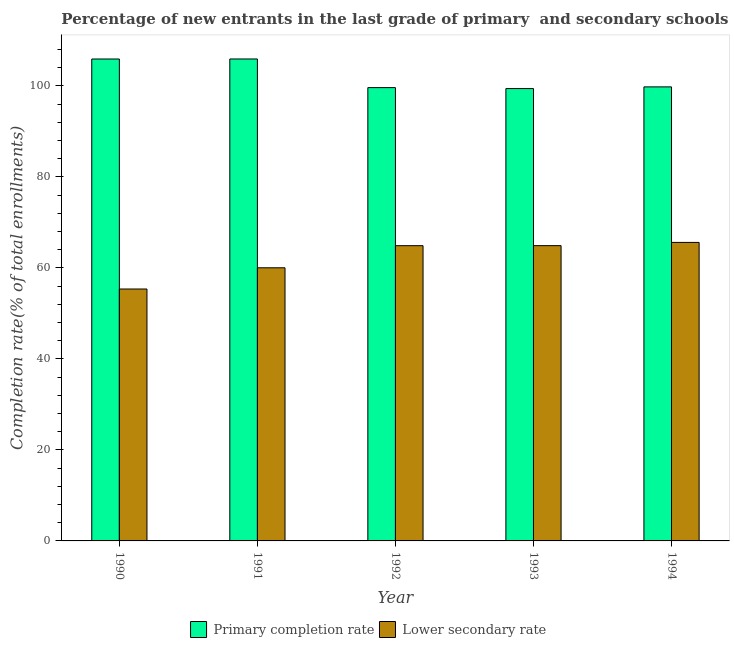How many different coloured bars are there?
Give a very brief answer. 2. How many groups of bars are there?
Keep it short and to the point. 5. In how many cases, is the number of bars for a given year not equal to the number of legend labels?
Provide a short and direct response. 0. What is the completion rate in primary schools in 1993?
Give a very brief answer. 99.42. Across all years, what is the maximum completion rate in primary schools?
Ensure brevity in your answer.  105.93. Across all years, what is the minimum completion rate in primary schools?
Give a very brief answer. 99.42. What is the total completion rate in secondary schools in the graph?
Keep it short and to the point. 310.79. What is the difference between the completion rate in secondary schools in 1992 and that in 1993?
Provide a short and direct response. -0.01. What is the difference between the completion rate in primary schools in 1994 and the completion rate in secondary schools in 1991?
Your answer should be very brief. -6.13. What is the average completion rate in primary schools per year?
Your answer should be compact. 102.14. In how many years, is the completion rate in secondary schools greater than 84 %?
Keep it short and to the point. 0. What is the ratio of the completion rate in secondary schools in 1990 to that in 1991?
Offer a terse response. 0.92. Is the difference between the completion rate in primary schools in 1992 and 1994 greater than the difference between the completion rate in secondary schools in 1992 and 1994?
Provide a succinct answer. No. What is the difference between the highest and the second highest completion rate in secondary schools?
Your response must be concise. 0.71. What is the difference between the highest and the lowest completion rate in primary schools?
Your answer should be compact. 6.5. In how many years, is the completion rate in secondary schools greater than the average completion rate in secondary schools taken over all years?
Your answer should be compact. 3. What does the 2nd bar from the left in 1990 represents?
Provide a short and direct response. Lower secondary rate. What does the 2nd bar from the right in 1992 represents?
Make the answer very short. Primary completion rate. What is the difference between two consecutive major ticks on the Y-axis?
Your answer should be compact. 20. Where does the legend appear in the graph?
Your answer should be compact. Bottom center. How many legend labels are there?
Ensure brevity in your answer.  2. What is the title of the graph?
Offer a very short reply. Percentage of new entrants in the last grade of primary  and secondary schools in China. What is the label or title of the X-axis?
Give a very brief answer. Year. What is the label or title of the Y-axis?
Ensure brevity in your answer.  Completion rate(% of total enrollments). What is the Completion rate(% of total enrollments) of Primary completion rate in 1990?
Make the answer very short. 105.92. What is the Completion rate(% of total enrollments) of Lower secondary rate in 1990?
Offer a terse response. 55.37. What is the Completion rate(% of total enrollments) of Primary completion rate in 1991?
Your response must be concise. 105.93. What is the Completion rate(% of total enrollments) of Lower secondary rate in 1991?
Provide a succinct answer. 60.03. What is the Completion rate(% of total enrollments) in Primary completion rate in 1992?
Ensure brevity in your answer.  99.63. What is the Completion rate(% of total enrollments) in Lower secondary rate in 1992?
Your answer should be very brief. 64.89. What is the Completion rate(% of total enrollments) of Primary completion rate in 1993?
Offer a very short reply. 99.42. What is the Completion rate(% of total enrollments) in Lower secondary rate in 1993?
Give a very brief answer. 64.9. What is the Completion rate(% of total enrollments) of Primary completion rate in 1994?
Provide a short and direct response. 99.79. What is the Completion rate(% of total enrollments) of Lower secondary rate in 1994?
Provide a short and direct response. 65.61. Across all years, what is the maximum Completion rate(% of total enrollments) of Primary completion rate?
Your answer should be very brief. 105.93. Across all years, what is the maximum Completion rate(% of total enrollments) of Lower secondary rate?
Offer a terse response. 65.61. Across all years, what is the minimum Completion rate(% of total enrollments) in Primary completion rate?
Offer a terse response. 99.42. Across all years, what is the minimum Completion rate(% of total enrollments) of Lower secondary rate?
Provide a short and direct response. 55.37. What is the total Completion rate(% of total enrollments) of Primary completion rate in the graph?
Offer a very short reply. 510.68. What is the total Completion rate(% of total enrollments) in Lower secondary rate in the graph?
Ensure brevity in your answer.  310.79. What is the difference between the Completion rate(% of total enrollments) in Primary completion rate in 1990 and that in 1991?
Provide a succinct answer. -0.01. What is the difference between the Completion rate(% of total enrollments) in Lower secondary rate in 1990 and that in 1991?
Your answer should be very brief. -4.66. What is the difference between the Completion rate(% of total enrollments) in Primary completion rate in 1990 and that in 1992?
Offer a very short reply. 6.29. What is the difference between the Completion rate(% of total enrollments) in Lower secondary rate in 1990 and that in 1992?
Ensure brevity in your answer.  -9.52. What is the difference between the Completion rate(% of total enrollments) of Primary completion rate in 1990 and that in 1993?
Your answer should be compact. 6.5. What is the difference between the Completion rate(% of total enrollments) of Lower secondary rate in 1990 and that in 1993?
Your answer should be very brief. -9.53. What is the difference between the Completion rate(% of total enrollments) of Primary completion rate in 1990 and that in 1994?
Ensure brevity in your answer.  6.13. What is the difference between the Completion rate(% of total enrollments) in Lower secondary rate in 1990 and that in 1994?
Ensure brevity in your answer.  -10.24. What is the difference between the Completion rate(% of total enrollments) in Primary completion rate in 1991 and that in 1992?
Give a very brief answer. 6.3. What is the difference between the Completion rate(% of total enrollments) in Lower secondary rate in 1991 and that in 1992?
Your response must be concise. -4.86. What is the difference between the Completion rate(% of total enrollments) in Primary completion rate in 1991 and that in 1993?
Your answer should be very brief. 6.5. What is the difference between the Completion rate(% of total enrollments) in Lower secondary rate in 1991 and that in 1993?
Give a very brief answer. -4.87. What is the difference between the Completion rate(% of total enrollments) in Primary completion rate in 1991 and that in 1994?
Your answer should be compact. 6.13. What is the difference between the Completion rate(% of total enrollments) in Lower secondary rate in 1991 and that in 1994?
Your response must be concise. -5.58. What is the difference between the Completion rate(% of total enrollments) in Primary completion rate in 1992 and that in 1993?
Your response must be concise. 0.21. What is the difference between the Completion rate(% of total enrollments) of Lower secondary rate in 1992 and that in 1993?
Give a very brief answer. -0.01. What is the difference between the Completion rate(% of total enrollments) of Primary completion rate in 1992 and that in 1994?
Your answer should be compact. -0.16. What is the difference between the Completion rate(% of total enrollments) of Lower secondary rate in 1992 and that in 1994?
Offer a very short reply. -0.72. What is the difference between the Completion rate(% of total enrollments) in Primary completion rate in 1993 and that in 1994?
Your answer should be compact. -0.37. What is the difference between the Completion rate(% of total enrollments) in Lower secondary rate in 1993 and that in 1994?
Offer a very short reply. -0.71. What is the difference between the Completion rate(% of total enrollments) of Primary completion rate in 1990 and the Completion rate(% of total enrollments) of Lower secondary rate in 1991?
Provide a succinct answer. 45.89. What is the difference between the Completion rate(% of total enrollments) of Primary completion rate in 1990 and the Completion rate(% of total enrollments) of Lower secondary rate in 1992?
Your answer should be very brief. 41.03. What is the difference between the Completion rate(% of total enrollments) of Primary completion rate in 1990 and the Completion rate(% of total enrollments) of Lower secondary rate in 1993?
Offer a very short reply. 41.02. What is the difference between the Completion rate(% of total enrollments) in Primary completion rate in 1990 and the Completion rate(% of total enrollments) in Lower secondary rate in 1994?
Provide a succinct answer. 40.31. What is the difference between the Completion rate(% of total enrollments) in Primary completion rate in 1991 and the Completion rate(% of total enrollments) in Lower secondary rate in 1992?
Provide a short and direct response. 41.03. What is the difference between the Completion rate(% of total enrollments) in Primary completion rate in 1991 and the Completion rate(% of total enrollments) in Lower secondary rate in 1993?
Provide a short and direct response. 41.03. What is the difference between the Completion rate(% of total enrollments) in Primary completion rate in 1991 and the Completion rate(% of total enrollments) in Lower secondary rate in 1994?
Provide a short and direct response. 40.32. What is the difference between the Completion rate(% of total enrollments) in Primary completion rate in 1992 and the Completion rate(% of total enrollments) in Lower secondary rate in 1993?
Keep it short and to the point. 34.73. What is the difference between the Completion rate(% of total enrollments) of Primary completion rate in 1992 and the Completion rate(% of total enrollments) of Lower secondary rate in 1994?
Keep it short and to the point. 34.02. What is the difference between the Completion rate(% of total enrollments) in Primary completion rate in 1993 and the Completion rate(% of total enrollments) in Lower secondary rate in 1994?
Your response must be concise. 33.81. What is the average Completion rate(% of total enrollments) of Primary completion rate per year?
Make the answer very short. 102.14. What is the average Completion rate(% of total enrollments) in Lower secondary rate per year?
Your answer should be compact. 62.16. In the year 1990, what is the difference between the Completion rate(% of total enrollments) in Primary completion rate and Completion rate(% of total enrollments) in Lower secondary rate?
Your answer should be compact. 50.55. In the year 1991, what is the difference between the Completion rate(% of total enrollments) of Primary completion rate and Completion rate(% of total enrollments) of Lower secondary rate?
Make the answer very short. 45.9. In the year 1992, what is the difference between the Completion rate(% of total enrollments) in Primary completion rate and Completion rate(% of total enrollments) in Lower secondary rate?
Offer a very short reply. 34.74. In the year 1993, what is the difference between the Completion rate(% of total enrollments) in Primary completion rate and Completion rate(% of total enrollments) in Lower secondary rate?
Your answer should be very brief. 34.52. In the year 1994, what is the difference between the Completion rate(% of total enrollments) in Primary completion rate and Completion rate(% of total enrollments) in Lower secondary rate?
Your answer should be compact. 34.18. What is the ratio of the Completion rate(% of total enrollments) of Primary completion rate in 1990 to that in 1991?
Ensure brevity in your answer.  1. What is the ratio of the Completion rate(% of total enrollments) of Lower secondary rate in 1990 to that in 1991?
Offer a very short reply. 0.92. What is the ratio of the Completion rate(% of total enrollments) of Primary completion rate in 1990 to that in 1992?
Provide a succinct answer. 1.06. What is the ratio of the Completion rate(% of total enrollments) in Lower secondary rate in 1990 to that in 1992?
Offer a very short reply. 0.85. What is the ratio of the Completion rate(% of total enrollments) in Primary completion rate in 1990 to that in 1993?
Provide a succinct answer. 1.07. What is the ratio of the Completion rate(% of total enrollments) of Lower secondary rate in 1990 to that in 1993?
Provide a succinct answer. 0.85. What is the ratio of the Completion rate(% of total enrollments) in Primary completion rate in 1990 to that in 1994?
Make the answer very short. 1.06. What is the ratio of the Completion rate(% of total enrollments) of Lower secondary rate in 1990 to that in 1994?
Keep it short and to the point. 0.84. What is the ratio of the Completion rate(% of total enrollments) of Primary completion rate in 1991 to that in 1992?
Make the answer very short. 1.06. What is the ratio of the Completion rate(% of total enrollments) in Lower secondary rate in 1991 to that in 1992?
Keep it short and to the point. 0.93. What is the ratio of the Completion rate(% of total enrollments) in Primary completion rate in 1991 to that in 1993?
Your answer should be very brief. 1.07. What is the ratio of the Completion rate(% of total enrollments) in Lower secondary rate in 1991 to that in 1993?
Your response must be concise. 0.93. What is the ratio of the Completion rate(% of total enrollments) of Primary completion rate in 1991 to that in 1994?
Make the answer very short. 1.06. What is the ratio of the Completion rate(% of total enrollments) in Lower secondary rate in 1991 to that in 1994?
Provide a succinct answer. 0.92. What is the difference between the highest and the second highest Completion rate(% of total enrollments) in Primary completion rate?
Offer a terse response. 0.01. What is the difference between the highest and the second highest Completion rate(% of total enrollments) in Lower secondary rate?
Provide a succinct answer. 0.71. What is the difference between the highest and the lowest Completion rate(% of total enrollments) in Primary completion rate?
Offer a very short reply. 6.5. What is the difference between the highest and the lowest Completion rate(% of total enrollments) in Lower secondary rate?
Make the answer very short. 10.24. 